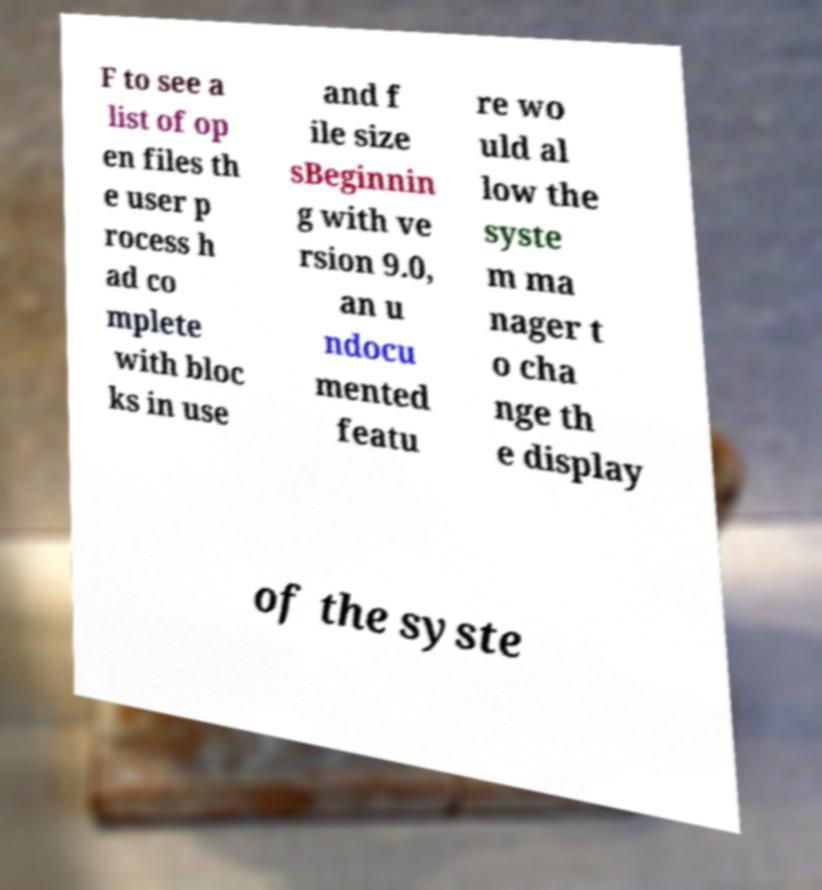Could you assist in decoding the text presented in this image and type it out clearly? F to see a list of op en files th e user p rocess h ad co mplete with bloc ks in use and f ile size sBeginnin g with ve rsion 9.0, an u ndocu mented featu re wo uld al low the syste m ma nager t o cha nge th e display of the syste 